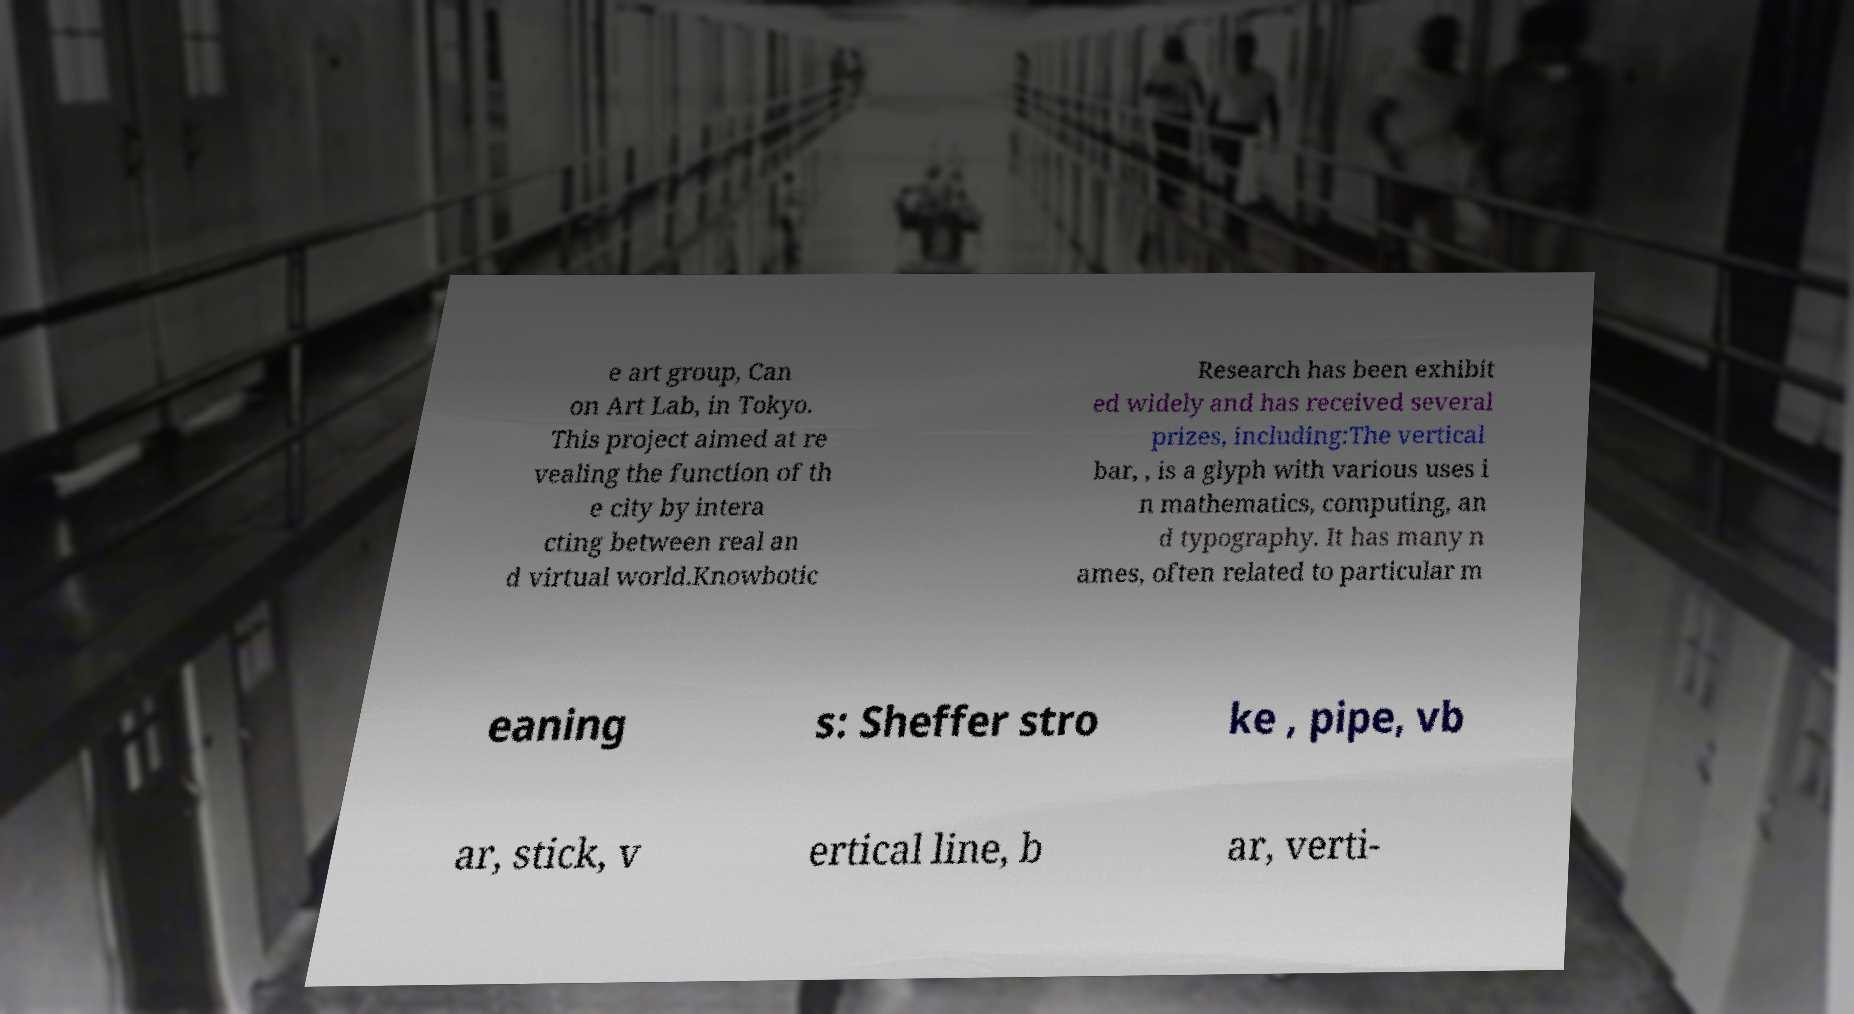I need the written content from this picture converted into text. Can you do that? e art group, Can on Art Lab, in Tokyo. This project aimed at re vealing the function of th e city by intera cting between real an d virtual world.Knowbotic Research has been exhibit ed widely and has received several prizes, including:The vertical bar, , is a glyph with various uses i n mathematics, computing, an d typography. It has many n ames, often related to particular m eaning s: Sheffer stro ke , pipe, vb ar, stick, v ertical line, b ar, verti- 